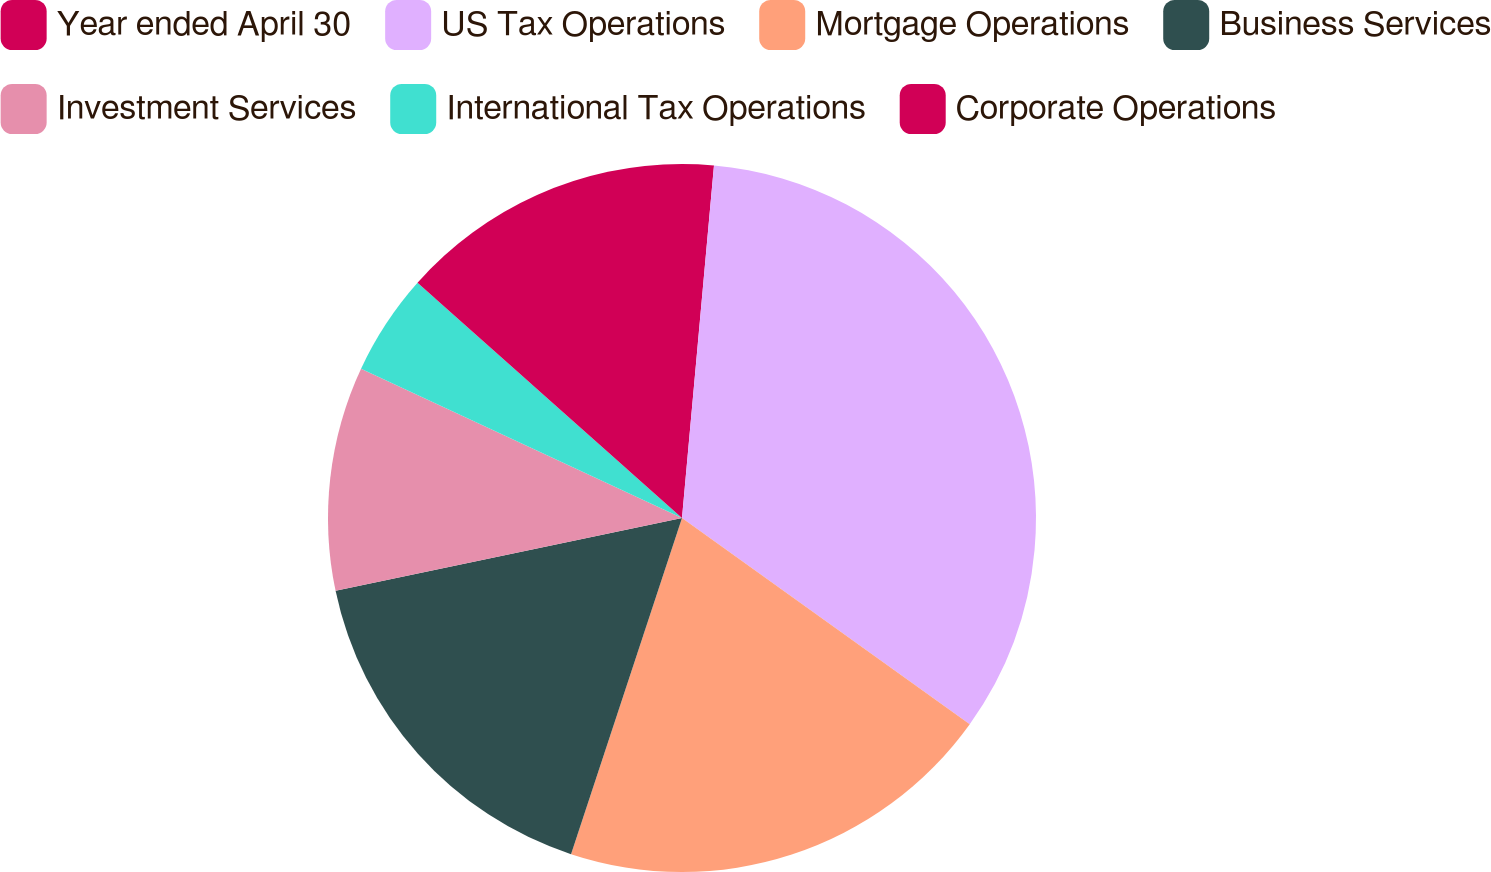Convert chart to OTSL. <chart><loc_0><loc_0><loc_500><loc_500><pie_chart><fcel>Year ended April 30<fcel>US Tax Operations<fcel>Mortgage Operations<fcel>Business Services<fcel>Investment Services<fcel>International Tax Operations<fcel>Corporate Operations<nl><fcel>1.44%<fcel>33.46%<fcel>20.18%<fcel>16.63%<fcel>10.23%<fcel>4.64%<fcel>13.43%<nl></chart> 